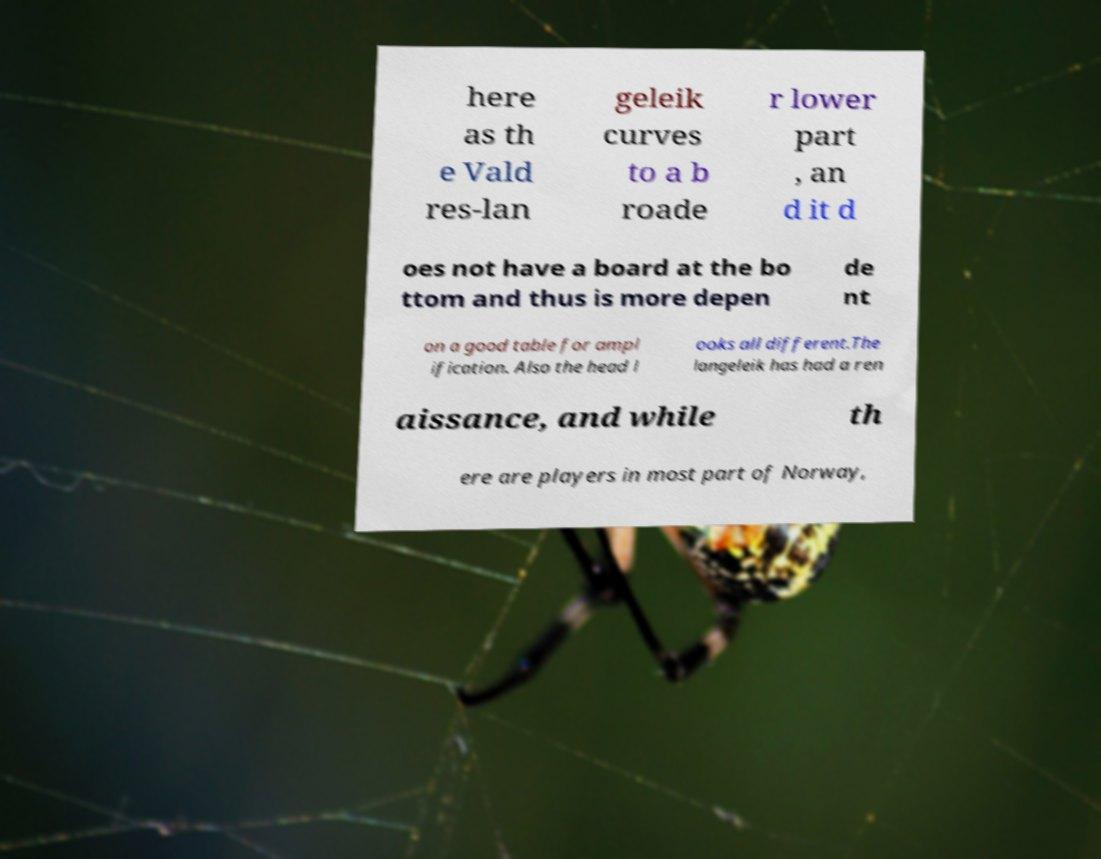Could you extract and type out the text from this image? here as th e Vald res-lan geleik curves to a b roade r lower part , an d it d oes not have a board at the bo ttom and thus is more depen de nt on a good table for ampl ification. Also the head l ooks all different.The langeleik has had a ren aissance, and while th ere are players in most part of Norway, 